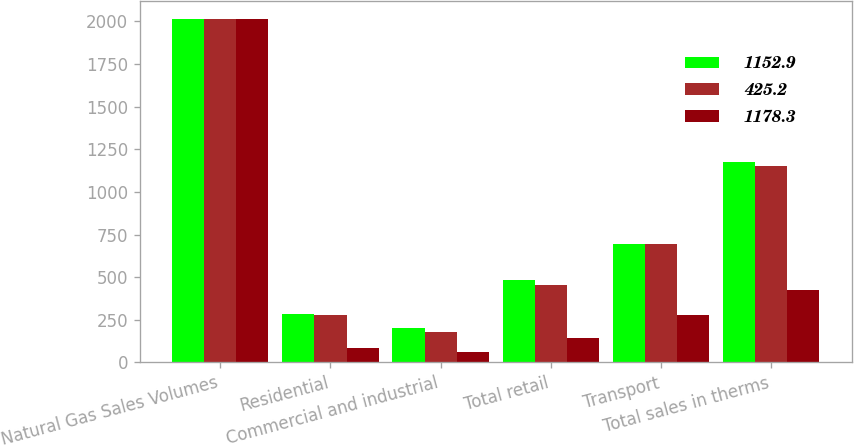Convert chart. <chart><loc_0><loc_0><loc_500><loc_500><stacked_bar_chart><ecel><fcel>Natural Gas Sales Volumes<fcel>Residential<fcel>Commercial and industrial<fcel>Total retail<fcel>Transport<fcel>Total sales in therms<nl><fcel>1152.9<fcel>2017<fcel>285.6<fcel>199.4<fcel>485<fcel>693.3<fcel>1178.3<nl><fcel>425.2<fcel>2016<fcel>278.5<fcel>178.2<fcel>456.7<fcel>696.2<fcel>1152.9<nl><fcel>1178.3<fcel>2015<fcel>84.7<fcel>60.9<fcel>145.6<fcel>279.6<fcel>425.2<nl></chart> 